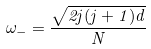<formula> <loc_0><loc_0><loc_500><loc_500>\omega _ { - } = \frac { \sqrt { 2 j ( j + 1 ) d } } { N }</formula> 